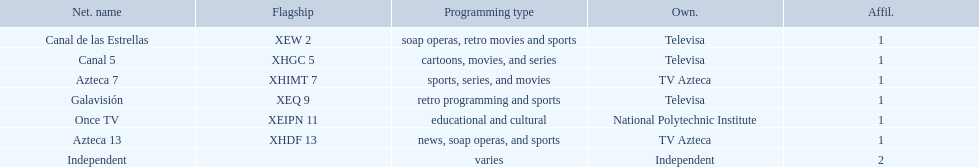Which owner only owns one network? National Polytechnic Institute, Independent. Of those, what is the network name? Once TV, Independent. Of those, which programming type is educational and cultural? Once TV. 